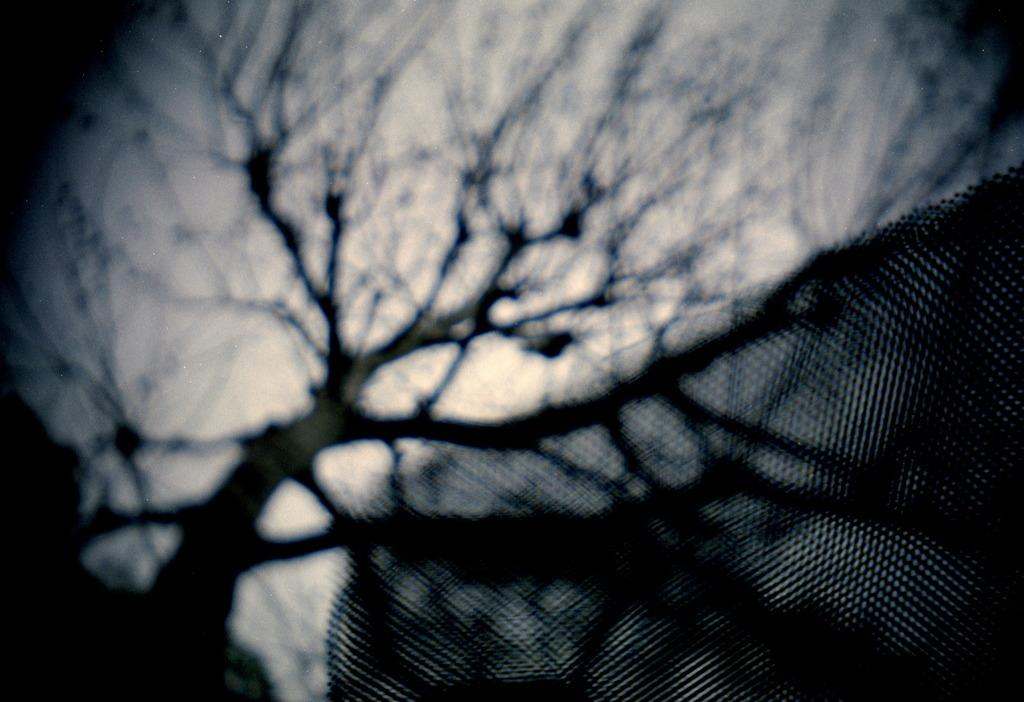What type of natural element can be seen in the image? There is a tree in the image. What is visible in the background of the image? The sky is visible in the background of the image. How would you describe the clarity of the image? The image is partially blurred. What type of scent can be detected from the tree in the image? There is no information about the scent of the tree in the image, as it is a visual representation only. 